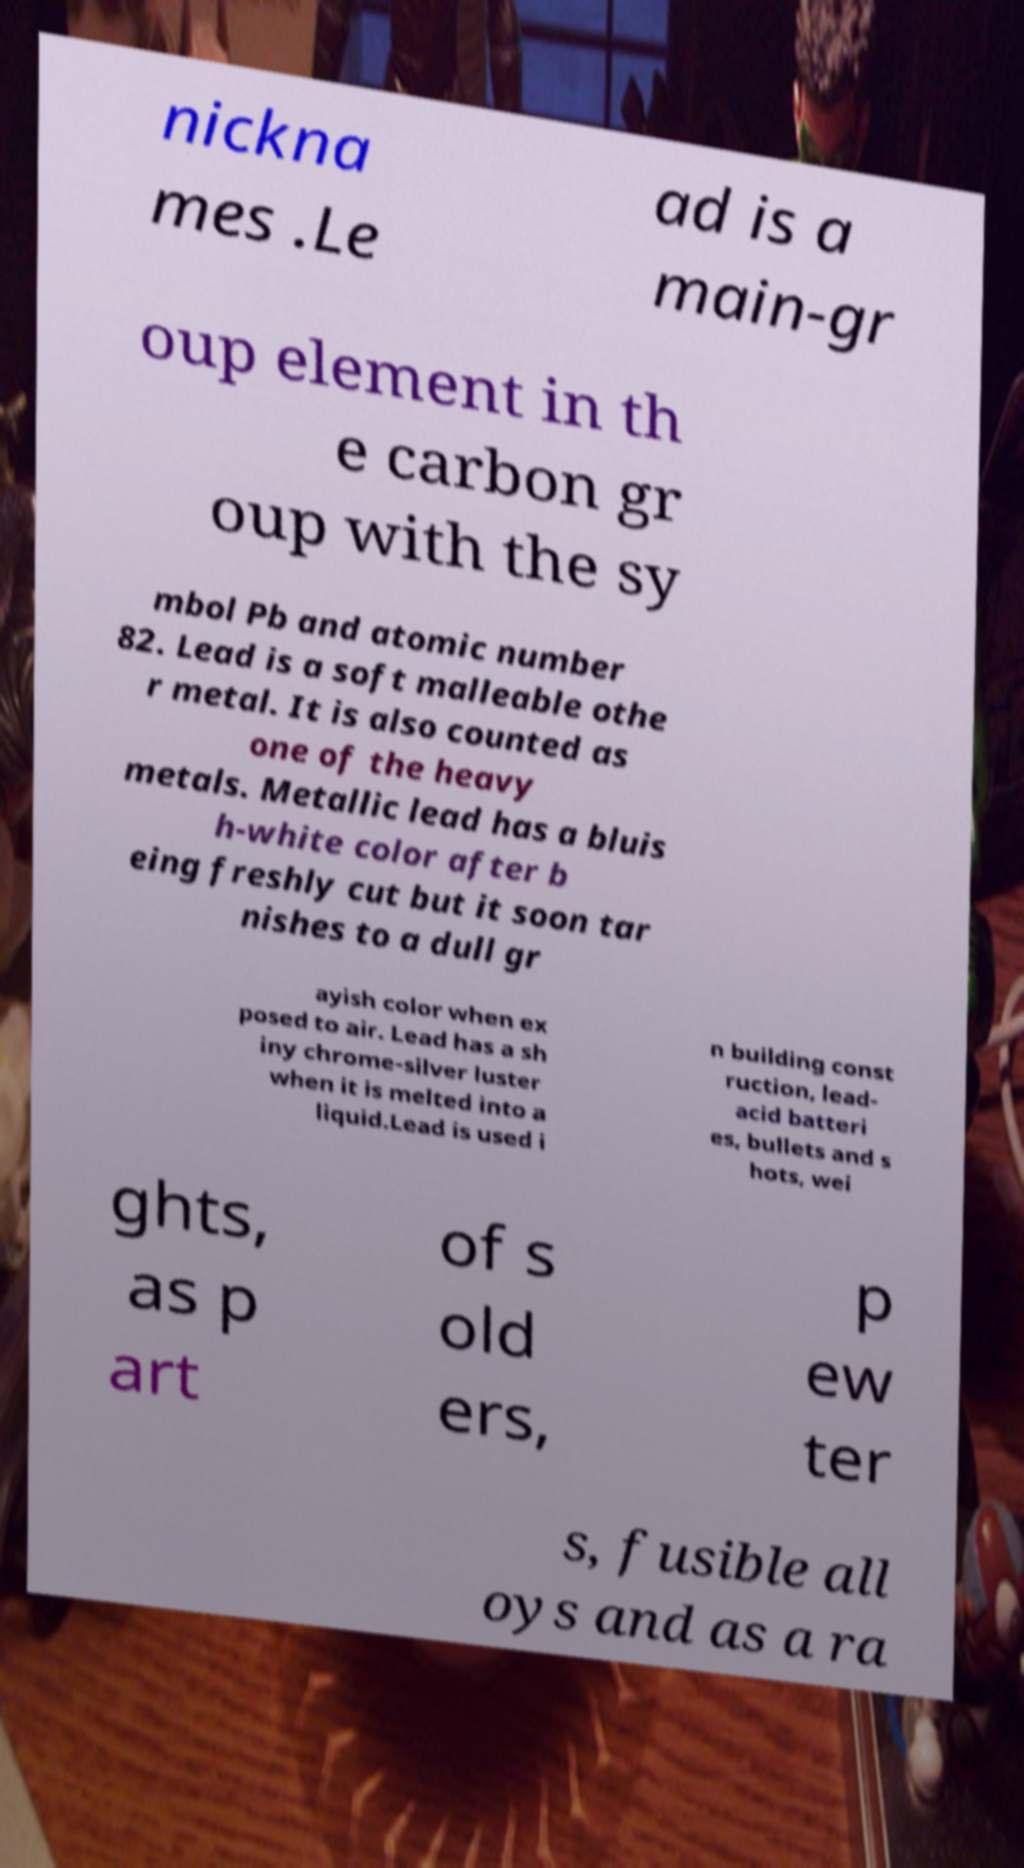Can you read and provide the text displayed in the image?This photo seems to have some interesting text. Can you extract and type it out for me? nickna mes .Le ad is a main-gr oup element in th e carbon gr oup with the sy mbol Pb and atomic number 82. Lead is a soft malleable othe r metal. It is also counted as one of the heavy metals. Metallic lead has a bluis h-white color after b eing freshly cut but it soon tar nishes to a dull gr ayish color when ex posed to air. Lead has a sh iny chrome-silver luster when it is melted into a liquid.Lead is used i n building const ruction, lead- acid batteri es, bullets and s hots, wei ghts, as p art of s old ers, p ew ter s, fusible all oys and as a ra 